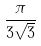<formula> <loc_0><loc_0><loc_500><loc_500>\frac { \pi } { 3 \sqrt { 3 } }</formula> 